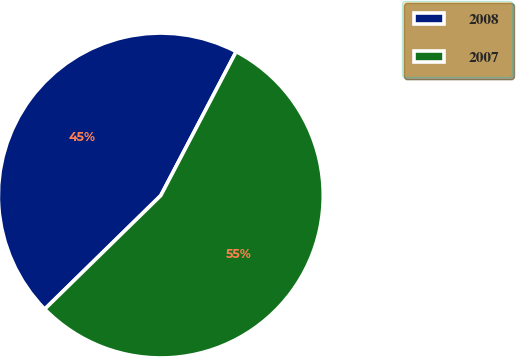Convert chart to OTSL. <chart><loc_0><loc_0><loc_500><loc_500><pie_chart><fcel>2008<fcel>2007<nl><fcel>45.01%<fcel>54.99%<nl></chart> 